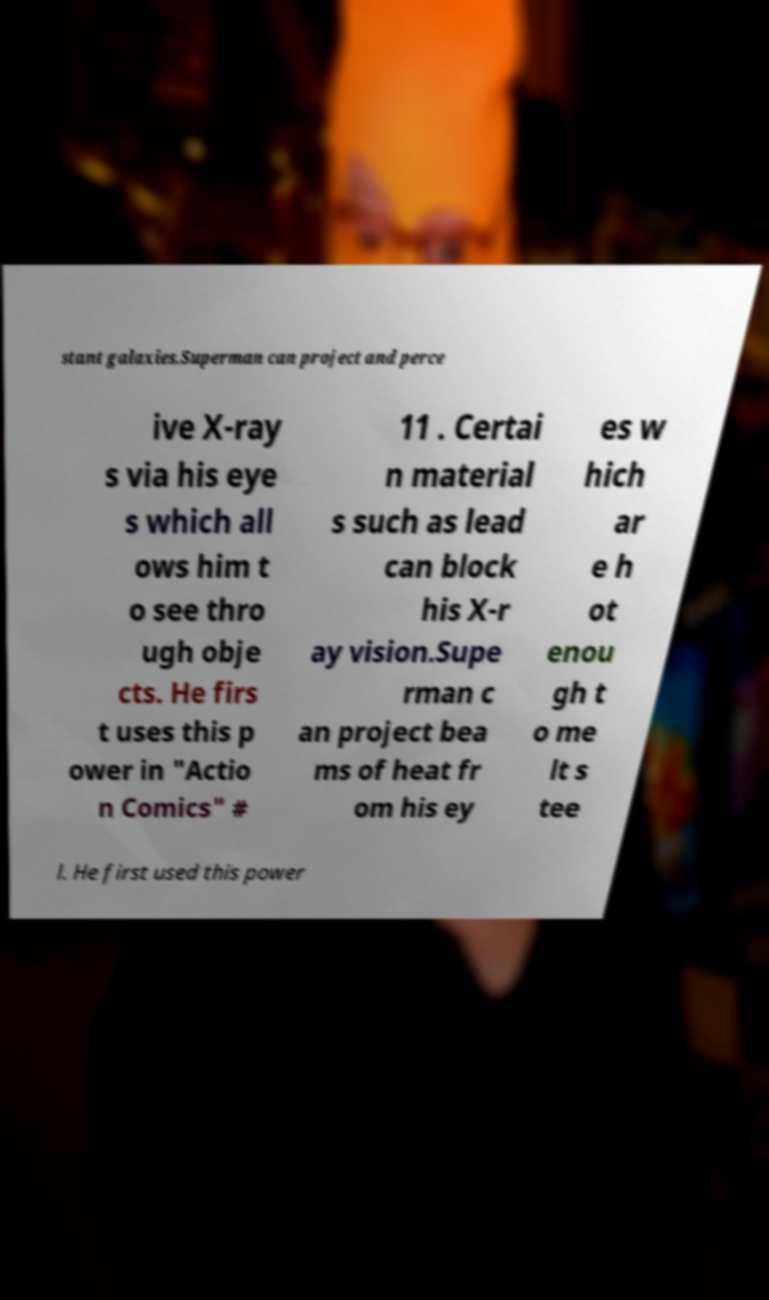What messages or text are displayed in this image? I need them in a readable, typed format. stant galaxies.Superman can project and perce ive X-ray s via his eye s which all ows him t o see thro ugh obje cts. He firs t uses this p ower in "Actio n Comics" # 11 . Certai n material s such as lead can block his X-r ay vision.Supe rman c an project bea ms of heat fr om his ey es w hich ar e h ot enou gh t o me lt s tee l. He first used this power 